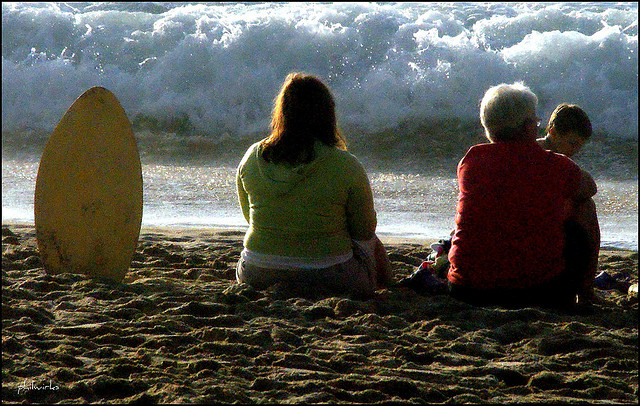<image>Is the man wearing glasses? I'm not sure if the man is wearing glasses. He could be wearing them or not. Is the man wearing glasses? I don't know if the man is wearing glasses. It can be both yes or no. 